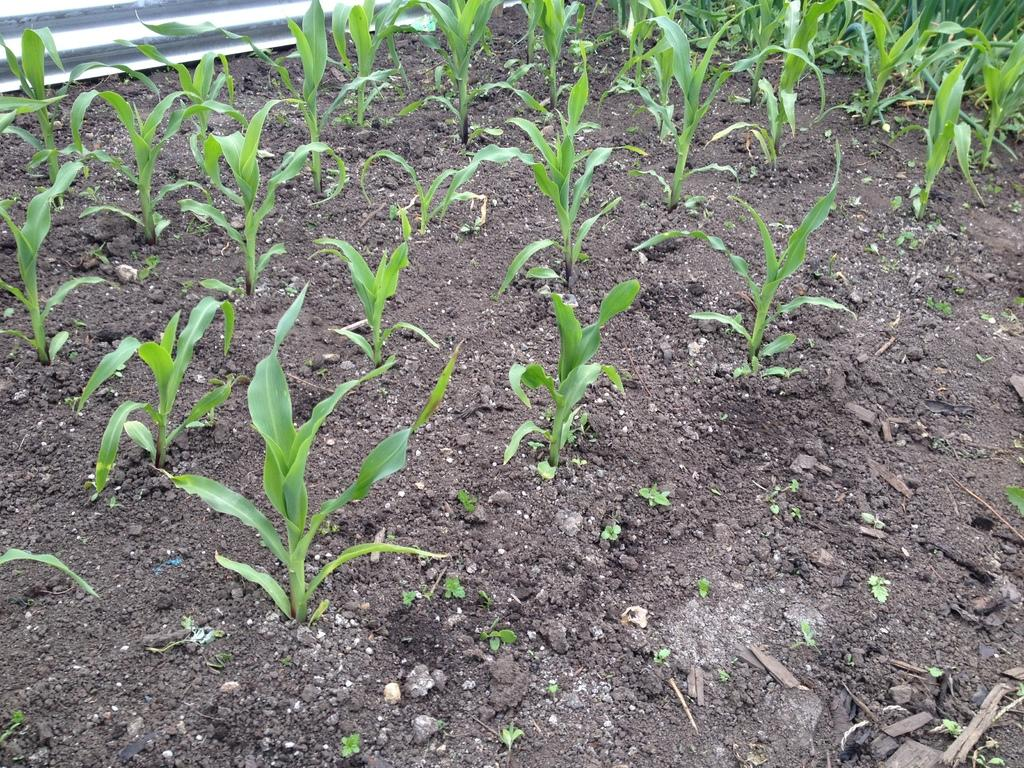What type of living organisms can be seen on the ground in the image? There are plants present on the ground in the image. What type of string is being used to hold up the tomatoes in the image? There are no tomatoes or strings present in the image; it only features plants on the ground. 